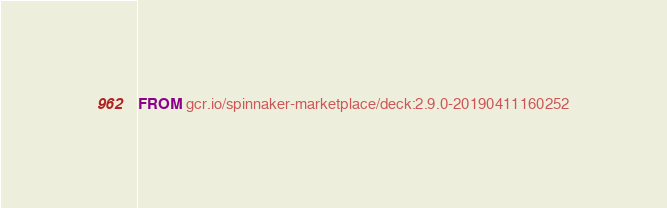<code> <loc_0><loc_0><loc_500><loc_500><_Dockerfile_>FROM gcr.io/spinnaker-marketplace/deck:2.9.0-20190411160252
</code> 